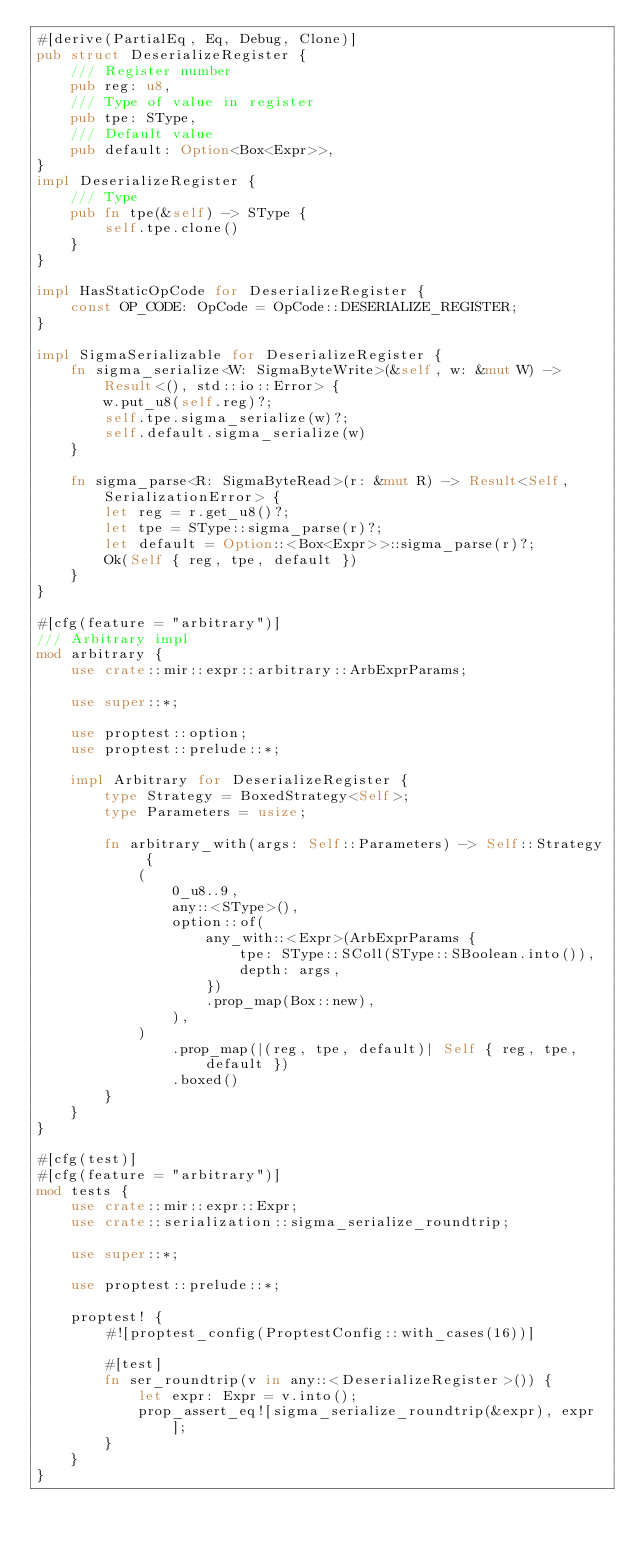<code> <loc_0><loc_0><loc_500><loc_500><_Rust_>#[derive(PartialEq, Eq, Debug, Clone)]
pub struct DeserializeRegister {
    /// Register number
    pub reg: u8,
    /// Type of value in register
    pub tpe: SType,
    /// Default value
    pub default: Option<Box<Expr>>,
}
impl DeserializeRegister {
    /// Type
    pub fn tpe(&self) -> SType {
        self.tpe.clone()
    }
}

impl HasStaticOpCode for DeserializeRegister {
    const OP_CODE: OpCode = OpCode::DESERIALIZE_REGISTER;
}

impl SigmaSerializable for DeserializeRegister {
    fn sigma_serialize<W: SigmaByteWrite>(&self, w: &mut W) -> Result<(), std::io::Error> {
        w.put_u8(self.reg)?;
        self.tpe.sigma_serialize(w)?;
        self.default.sigma_serialize(w)
    }

    fn sigma_parse<R: SigmaByteRead>(r: &mut R) -> Result<Self, SerializationError> {
        let reg = r.get_u8()?;
        let tpe = SType::sigma_parse(r)?;
        let default = Option::<Box<Expr>>::sigma_parse(r)?;
        Ok(Self { reg, tpe, default })
    }
}

#[cfg(feature = "arbitrary")]
/// Arbitrary impl
mod arbitrary {
    use crate::mir::expr::arbitrary::ArbExprParams;

    use super::*;

    use proptest::option;
    use proptest::prelude::*;

    impl Arbitrary for DeserializeRegister {
        type Strategy = BoxedStrategy<Self>;
        type Parameters = usize;

        fn arbitrary_with(args: Self::Parameters) -> Self::Strategy {
            (
                0_u8..9,
                any::<SType>(),
                option::of(
                    any_with::<Expr>(ArbExprParams {
                        tpe: SType::SColl(SType::SBoolean.into()),
                        depth: args,
                    })
                    .prop_map(Box::new),
                ),
            )
                .prop_map(|(reg, tpe, default)| Self { reg, tpe, default })
                .boxed()
        }
    }
}

#[cfg(test)]
#[cfg(feature = "arbitrary")]
mod tests {
    use crate::mir::expr::Expr;
    use crate::serialization::sigma_serialize_roundtrip;

    use super::*;

    use proptest::prelude::*;

    proptest! {
        #![proptest_config(ProptestConfig::with_cases(16))]

        #[test]
        fn ser_roundtrip(v in any::<DeserializeRegister>()) {
            let expr: Expr = v.into();
            prop_assert_eq![sigma_serialize_roundtrip(&expr), expr];
        }
    }
}
</code> 